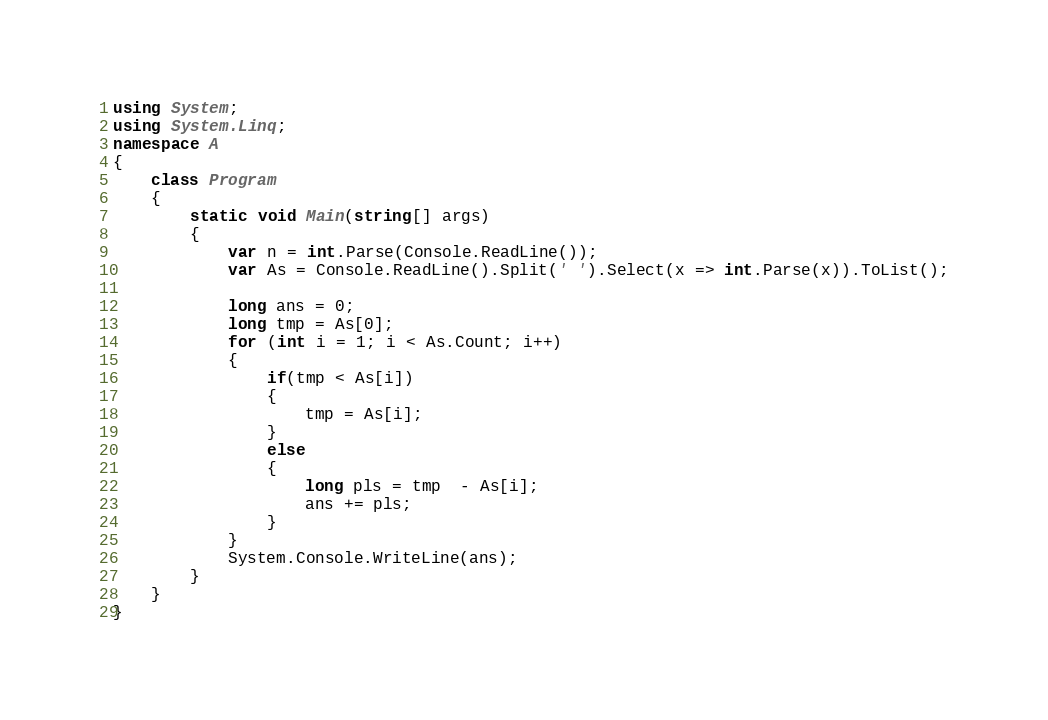<code> <loc_0><loc_0><loc_500><loc_500><_C#_>using System;
using System.Linq;
namespace A
{
    class Program
    {
        static void Main(string[] args)
        {
            var n = int.Parse(Console.ReadLine());
            var As = Console.ReadLine().Split(' ').Select(x => int.Parse(x)).ToList();

            long ans = 0;
            long tmp = As[0];
            for (int i = 1; i < As.Count; i++)
            {
                if(tmp < As[i])
                {
                    tmp = As[i];
                }
                else
                {
                    long pls = tmp  - As[i];
                    ans += pls;
                }
            }
            System.Console.WriteLine(ans);
        }
    }
}
</code> 